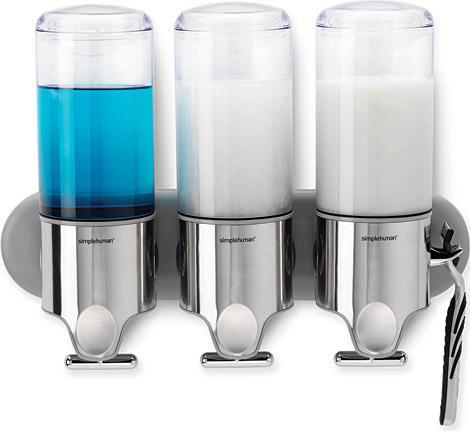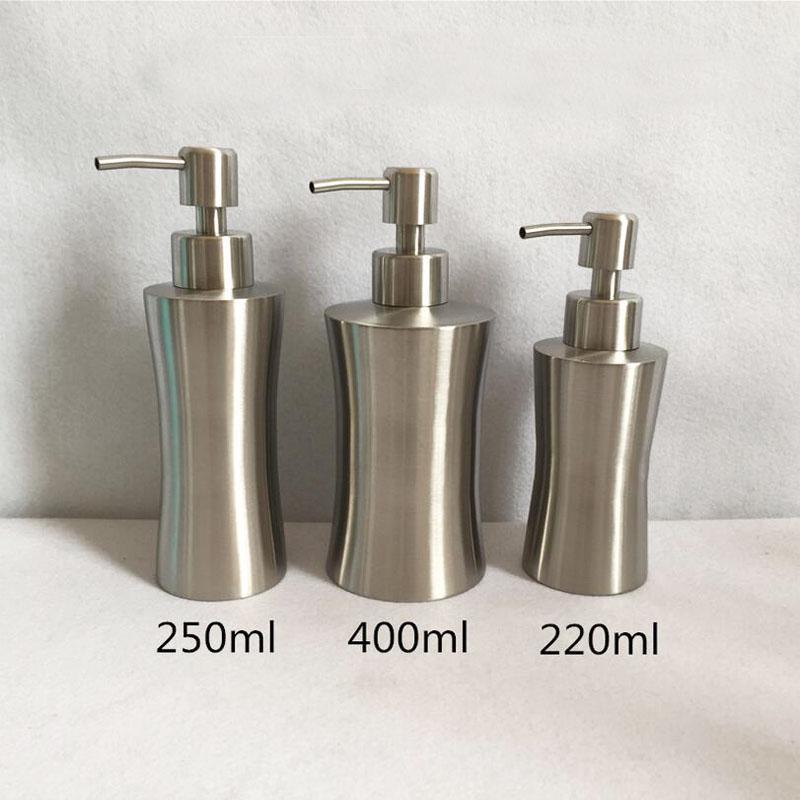The first image is the image on the left, the second image is the image on the right. For the images displayed, is the sentence "The image to the right features three soap dispensers." factually correct? Answer yes or no. Yes. The first image is the image on the left, the second image is the image on the right. For the images displayed, is the sentence "Both images contain three liquid bathroom product dispensers." factually correct? Answer yes or no. Yes. 